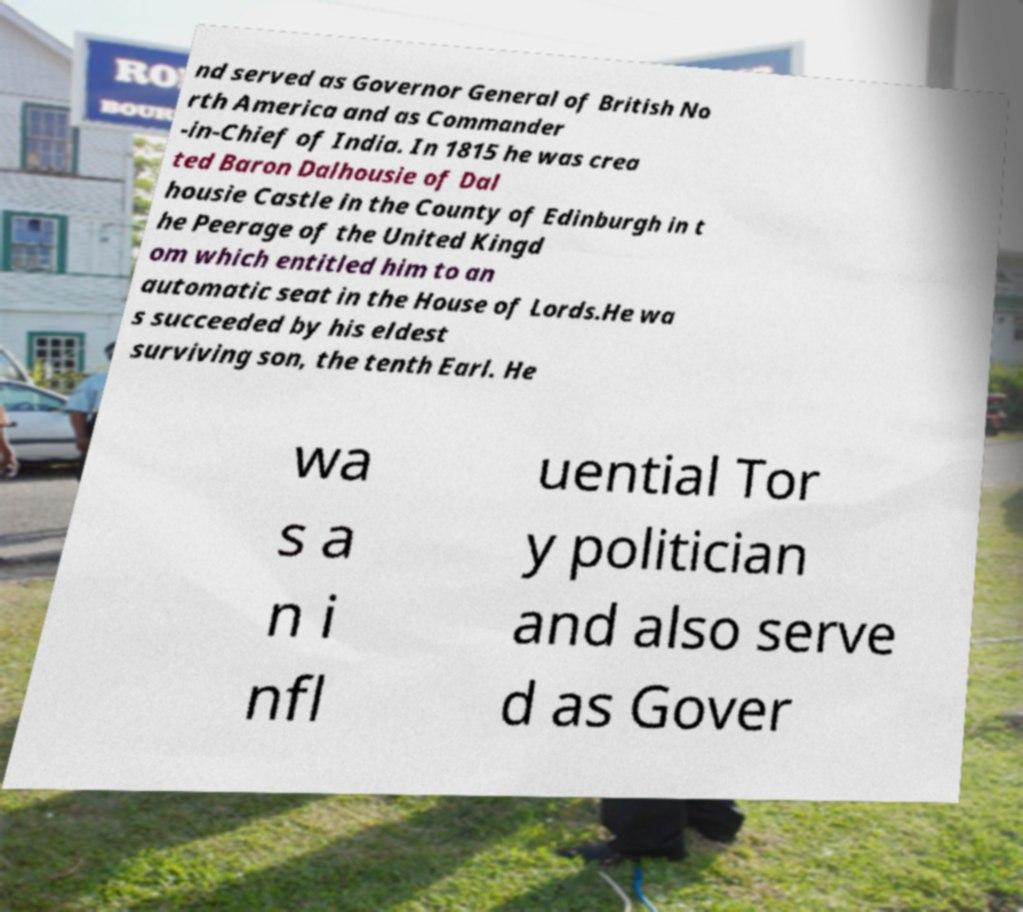Can you accurately transcribe the text from the provided image for me? nd served as Governor General of British No rth America and as Commander -in-Chief of India. In 1815 he was crea ted Baron Dalhousie of Dal housie Castle in the County of Edinburgh in t he Peerage of the United Kingd om which entitled him to an automatic seat in the House of Lords.He wa s succeeded by his eldest surviving son, the tenth Earl. He wa s a n i nfl uential Tor y politician and also serve d as Gover 